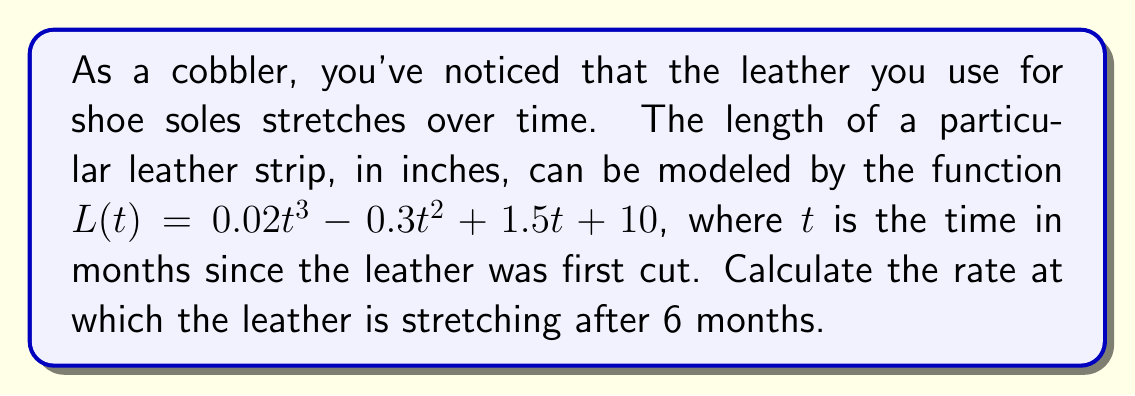Give your solution to this math problem. To find the rate at which the leather is stretching after 6 months, we need to calculate the derivative of the length function $L(t)$ and evaluate it at $t=6$. This will give us the instantaneous rate of change.

Step 1: Find the derivative of $L(t)$
$$L(t) = 0.02t^3 - 0.3t^2 + 1.5t + 10$$
$$L'(t) = 0.06t^2 - 0.6t + 1.5$$

Step 2: Evaluate $L'(t)$ at $t=6$
$$L'(6) = 0.06(6)^2 - 0.6(6) + 1.5$$
$$L'(6) = 0.06(36) - 3.6 + 1.5$$
$$L'(6) = 2.16 - 3.6 + 1.5$$
$$L'(6) = 0.06$$

Step 3: Interpret the result
The rate of change at 6 months is 0.06 inches per month. This means the leather is stretching at a rate of 0.06 inches per month after 6 months.
Answer: 0.06 inches per month 